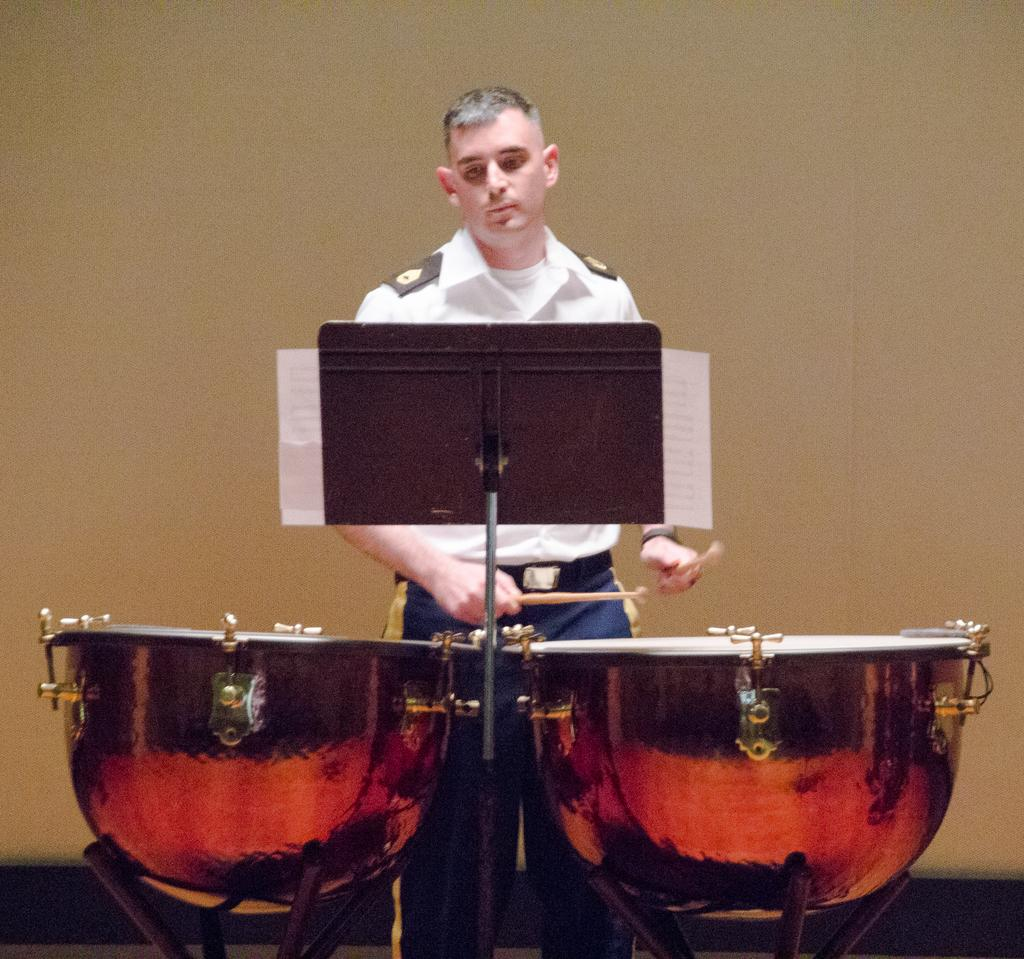What is the main subject of the image? There is a person in the image. What is the person doing in the image? The person is playing drums. Where are the drums located in relation to the person? The drums are in front of the person. What is the plank with a stand used for in the image? The plank with a stand is likely used as a platform for the drums. What type of plants can be seen in the background of the image? There are no plants visible in the image. What topic are the people discussing in the image? There are no people engaged in a discussion in the image; it only features a person playing drums. 